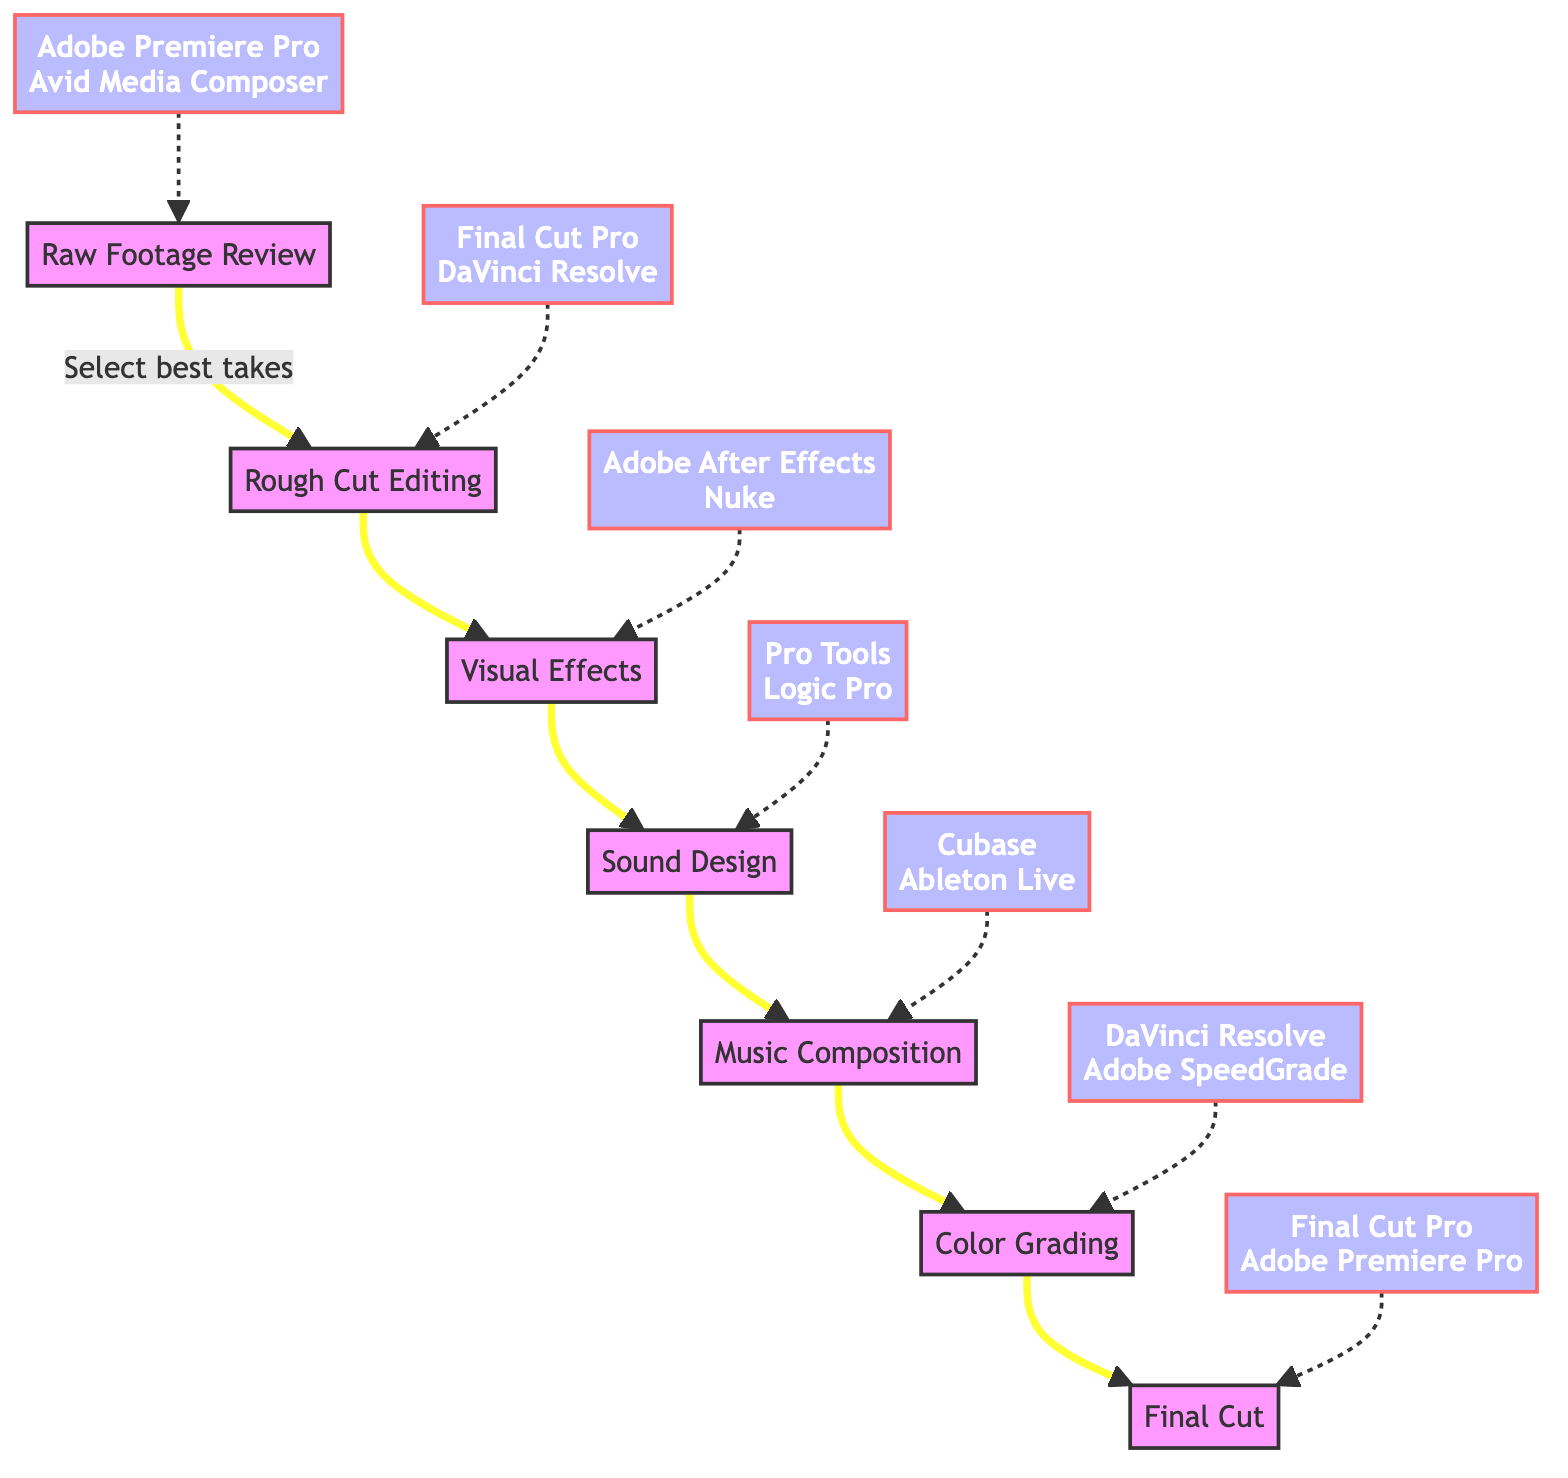What is the first step in the post-production workflow? The diagram shows that the first node is "Raw Footage Review," indicating that this is the initial step in the workflow.
Answer: Raw Footage Review How many main steps are there in the post-production workflow? By counting the nodes from "Raw Footage Review" to "Final Cut," there are a total of six distinct steps presented in the diagram.
Answer: 6 Which tools are used for Rough Cut Editing? The diagram indicates that the tools associated with "Rough Cut Editing" are "Final Cut Pro" and "DaVinci Resolve."
Answer: Final Cut Pro, DaVinci Resolve What is the step after Color Grading? Following the flow in the diagram, "Color Grading" leads to "Final Cut," making it the next step after Color Grading.
Answer: Final Cut Which step involves integrating sound effects? The diagram shows that "Sound Design" is the step focused on designing and integrating sound effects, ambiance, and Foley.
Answer: Sound Design What is the purpose of the Visual Effects step? The description for the "Visual Effects" step states it is to "Add and refine visual effects to enhance the visual storytelling," indicating its main purpose.
Answer: Enhance visual storytelling Which tools would be used in the Color Grading step? According to the diagram, "DaVinci Resolve" and "Adobe SpeedGrade" are the tools associated with the "Color Grading" step.
Answer: DaVinci Resolve, Adobe SpeedGrade What is the relationship between Rough Cut Editing and Visual Effects? The diagram indicates a direct flow from "Rough Cut Editing" to "Visual Effects," showing that Visual Effects immediately follows Rough Cut Editing in the workflow.
Answer: Direct flow What step comes before Music Composition? By following the flowchart, the step that precedes "Music Composition" is "Sound Design," indicating its position in the sequence.
Answer: Sound Design 